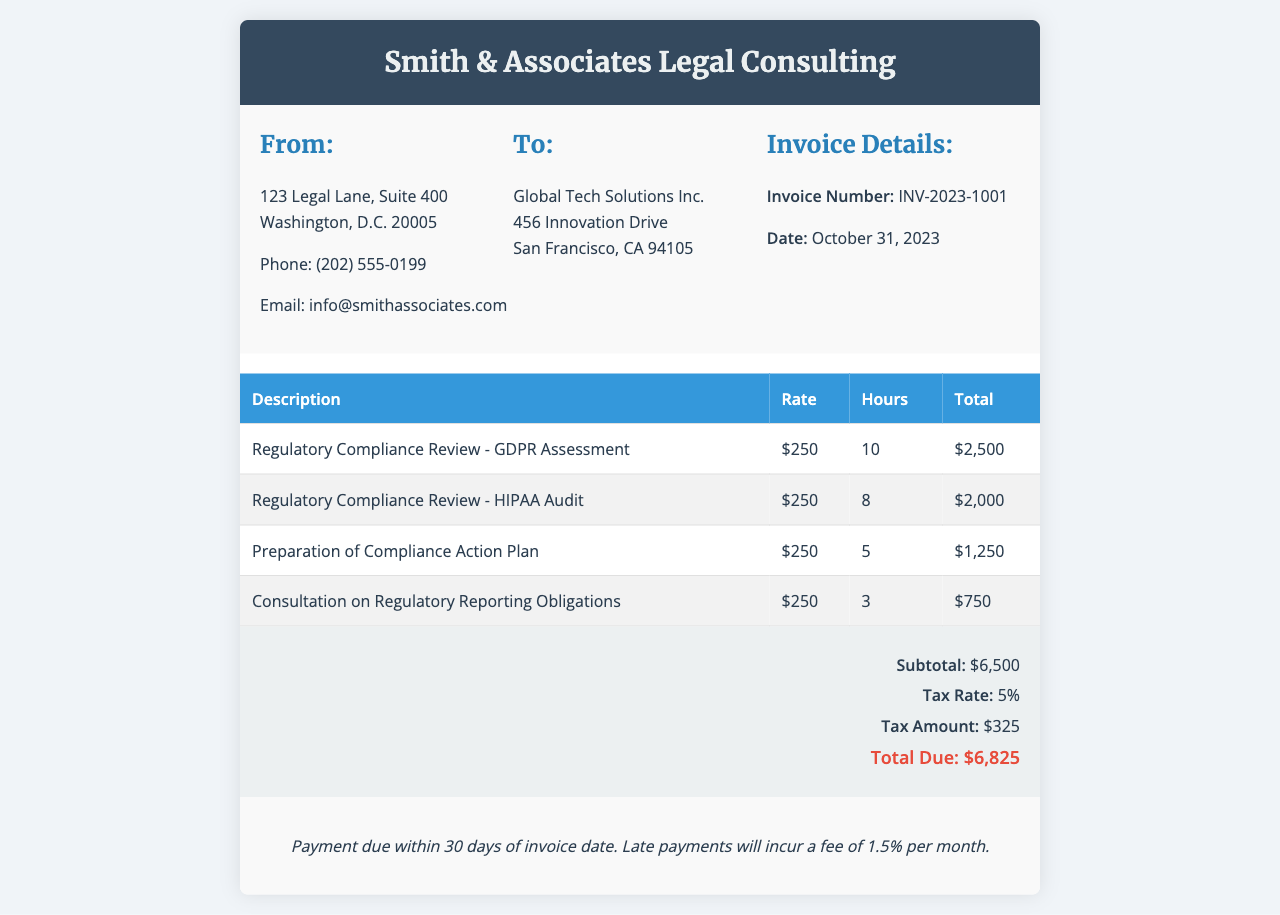What is the invoice number? The invoice number is listed in the invoice details section.
Answer: INV-2023-1001 What is the total due amount? The total due amount is calculated at the bottom of the invoice summary.
Answer: $6,825 How many hours were spent on the HIPAA Audit? The hours for each service are specified in the invoice table under the “Hours” column.
Answer: 8 What is the tax rate applied to this invoice? The tax rate is mentioned in the invoice summary section.
Answer: 5% What is the name of the consulting firm? The name of the consulting firm is displayed in the header of the invoice.
Answer: Smith & Associates Legal Consulting How much was charged for the preparation of the Compliance Action Plan? The charge is indicated in the invoice table under "Total" for that specific service.
Answer: $1,250 When is the payment due? The payment terms section provides information about the payment due date.
Answer: Within 30 days How many total hours were worked on the Regulatory Compliance Review services? To find the total hours, the hours from each service in the table must be added together.
Answer: 26 What type of services were provided? The services are listed in the description column of the invoice table.
Answer: Regulatory Compliance Review services 